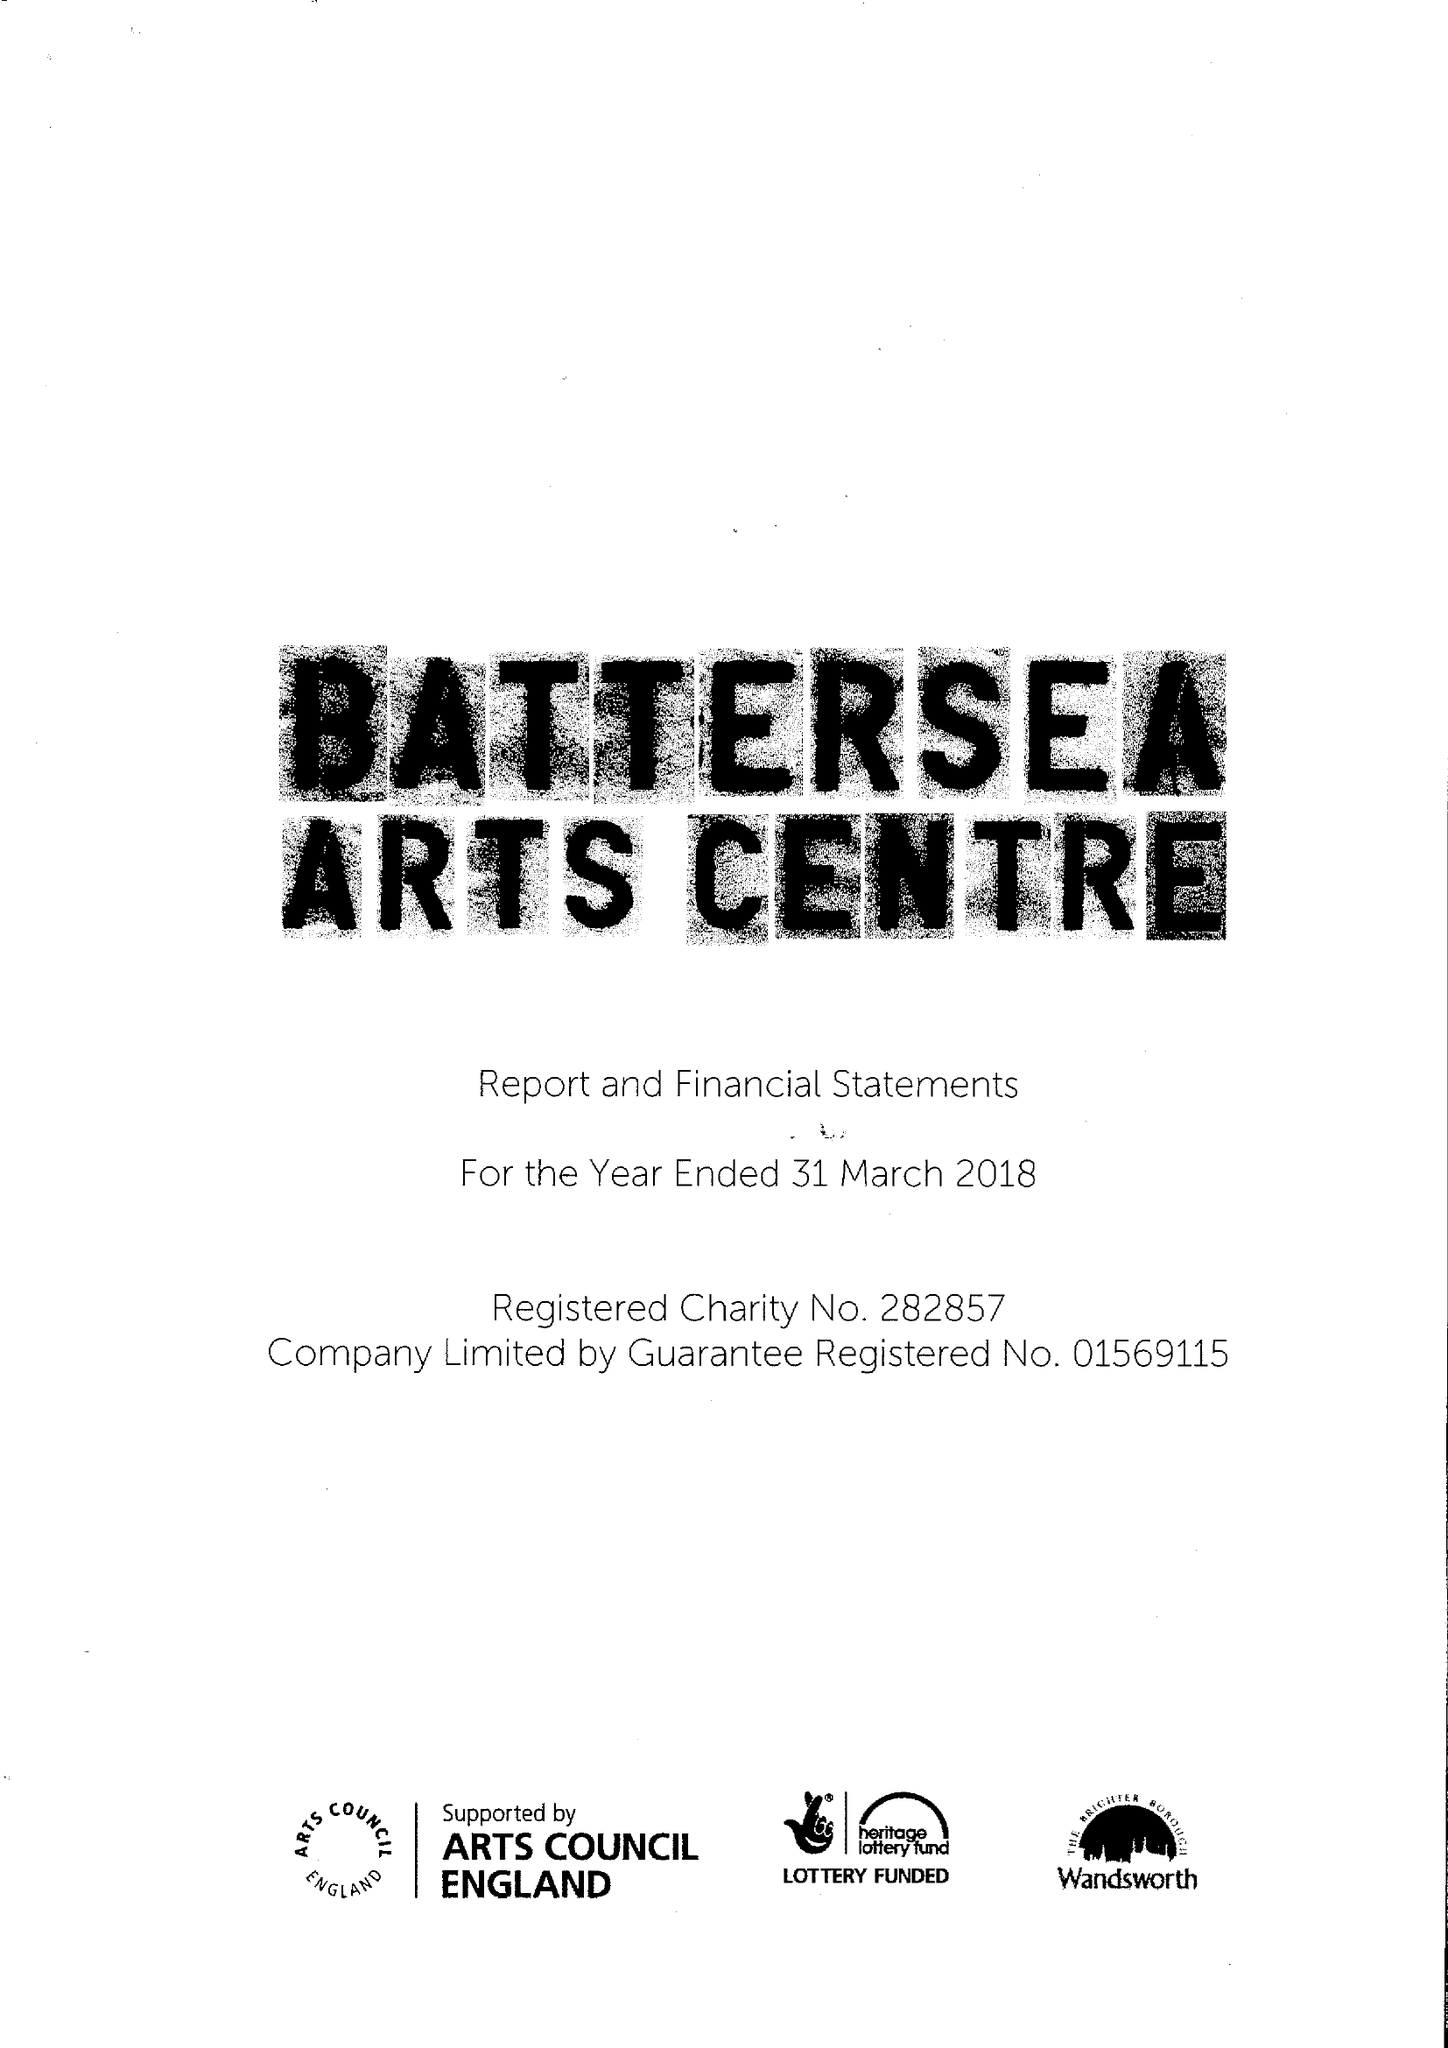What is the value for the income_annually_in_british_pounds?
Answer the question using a single word or phrase. 12300166.00 